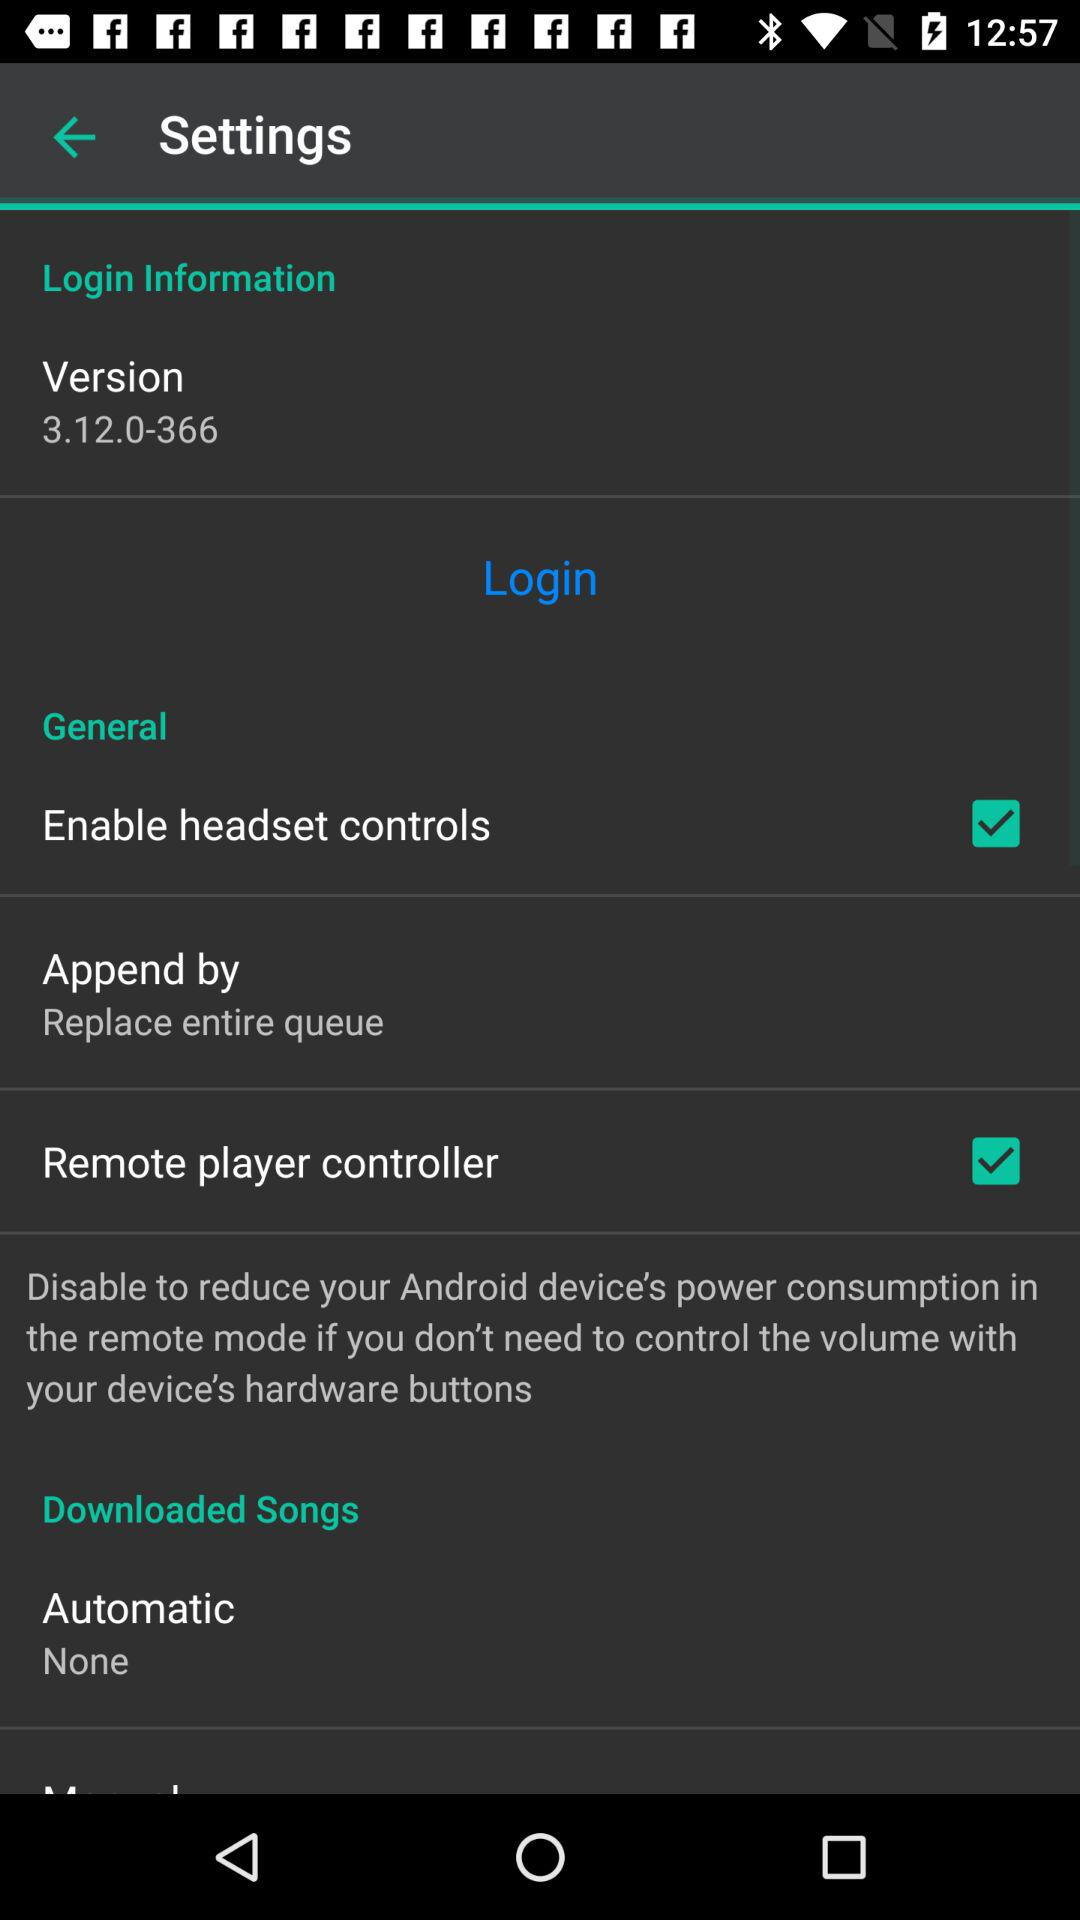What is the status of "Enable headset controls" in "General"? The status is "on". 